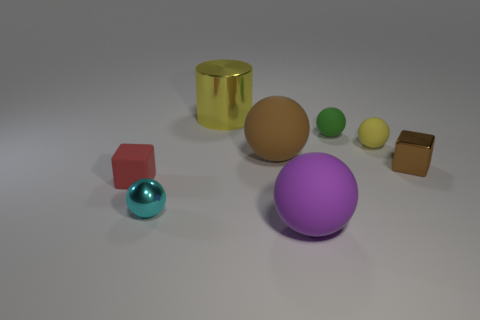Add 1 brown matte things. How many objects exist? 9 Subtract all cyan spheres. How many spheres are left? 4 Subtract all tiny yellow matte balls. How many balls are left? 4 Subtract all spheres. How many objects are left? 3 Subtract all blue spheres. Subtract all purple blocks. How many spheres are left? 5 Subtract all tiny cyan rubber cylinders. Subtract all yellow shiny cylinders. How many objects are left? 7 Add 2 tiny brown metal objects. How many tiny brown metal objects are left? 3 Add 6 big purple metal things. How many big purple metal things exist? 6 Subtract 0 green blocks. How many objects are left? 8 